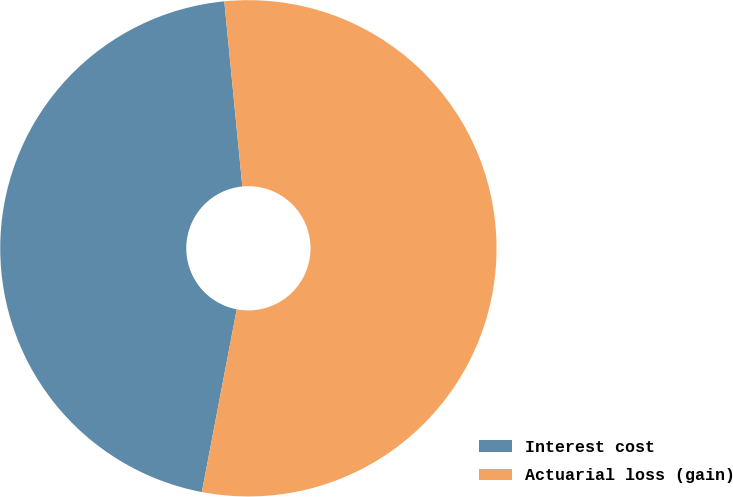Convert chart. <chart><loc_0><loc_0><loc_500><loc_500><pie_chart><fcel>Interest cost<fcel>Actuarial loss (gain)<nl><fcel>45.45%<fcel>54.55%<nl></chart> 